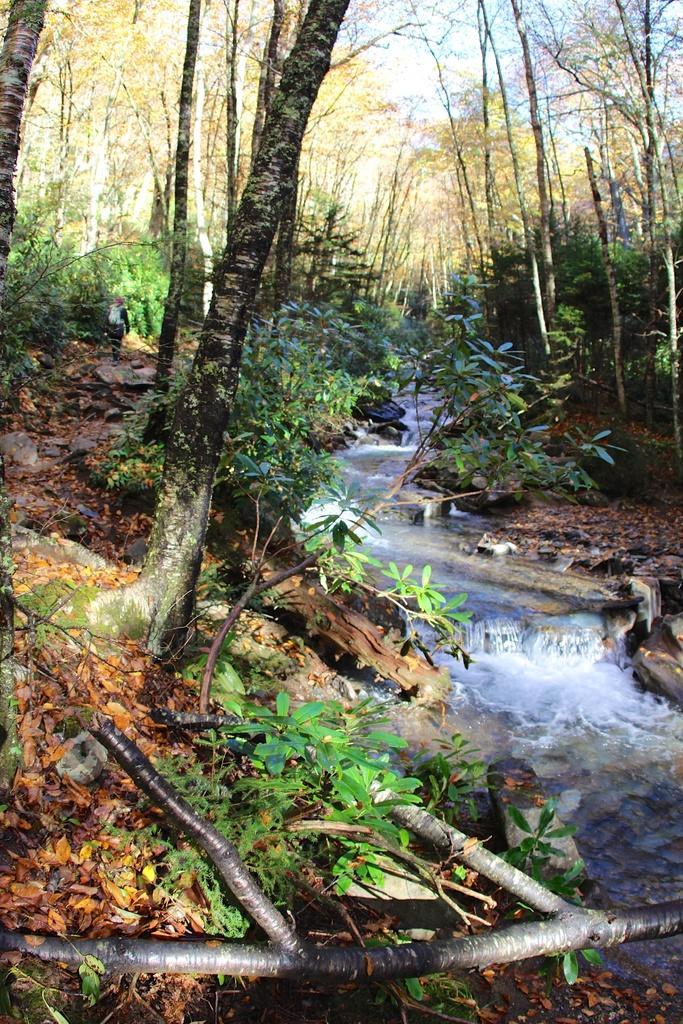Describe this image in one or two sentences. This picture shows trees and we see few plants and water flowing. 